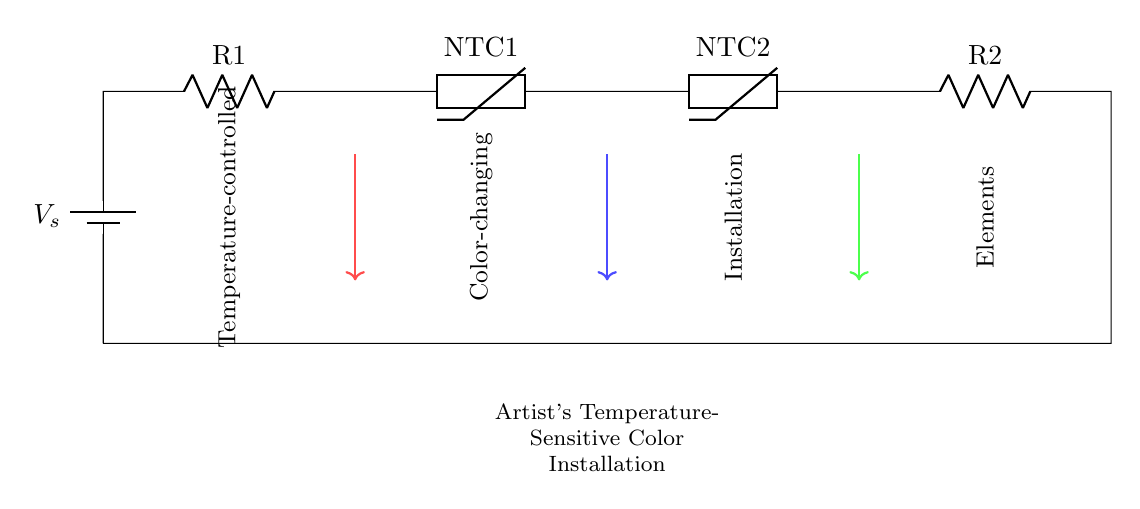What is the power source in this circuit? The power source is a battery, represented as "V_s" in the circuit diagram. It supplies the necessary voltage for the operation of the other components in the series.
Answer: battery How many thermistors are present in the circuit? There are two thermistors in the circuit, labeled as "NTC1" and "NTC2." Both are connected in series and are important for temperature sensing.
Answer: two What can be inferred about the temperature response of the NTC thermistors? NTC thermistors have a negative temperature coefficient, meaning that their resistance decreases as temperature increases. This suggests that the color-changing features will respond inversely to temperature changes.
Answer: resistance decrease What do the colored arrows in the diagram represent? The colored arrows indicate the flow of current or signals through the circuit, highlighting the interaction and control elements integrated within the installation for temperature sensitivity.
Answer: current flow What role do the resistors play in this circuit? The resistors, identified as "R1" and "R2," interact with the thermistors to create a voltage divider that helps in signaling temperature changes, which in turn affects the color of the installation.
Answer: signal adjustment What is the overall purpose of this circuit diagram? The circuit diagram is designed for a temperature-sensitive color-changing installation, intended for artistic expression by integrating electronic components that respond to environmental conditions.
Answer: color changing installation 